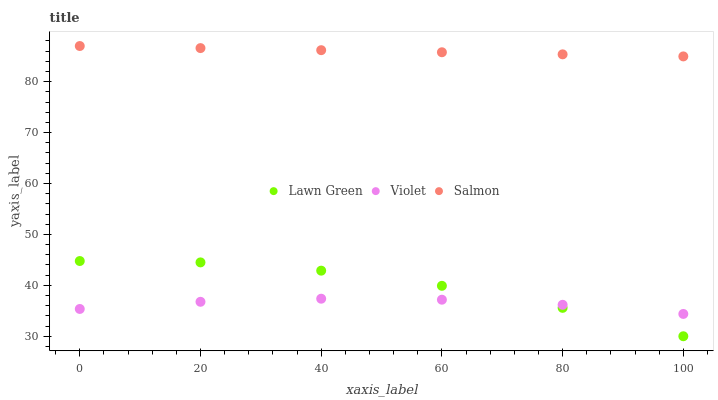Does Violet have the minimum area under the curve?
Answer yes or no. Yes. Does Salmon have the maximum area under the curve?
Answer yes or no. Yes. Does Salmon have the minimum area under the curve?
Answer yes or no. No. Does Violet have the maximum area under the curve?
Answer yes or no. No. Is Salmon the smoothest?
Answer yes or no. Yes. Is Lawn Green the roughest?
Answer yes or no. Yes. Is Violet the smoothest?
Answer yes or no. No. Is Violet the roughest?
Answer yes or no. No. Does Lawn Green have the lowest value?
Answer yes or no. Yes. Does Violet have the lowest value?
Answer yes or no. No. Does Salmon have the highest value?
Answer yes or no. Yes. Does Violet have the highest value?
Answer yes or no. No. Is Lawn Green less than Salmon?
Answer yes or no. Yes. Is Salmon greater than Violet?
Answer yes or no. Yes. Does Violet intersect Lawn Green?
Answer yes or no. Yes. Is Violet less than Lawn Green?
Answer yes or no. No. Is Violet greater than Lawn Green?
Answer yes or no. No. Does Lawn Green intersect Salmon?
Answer yes or no. No. 